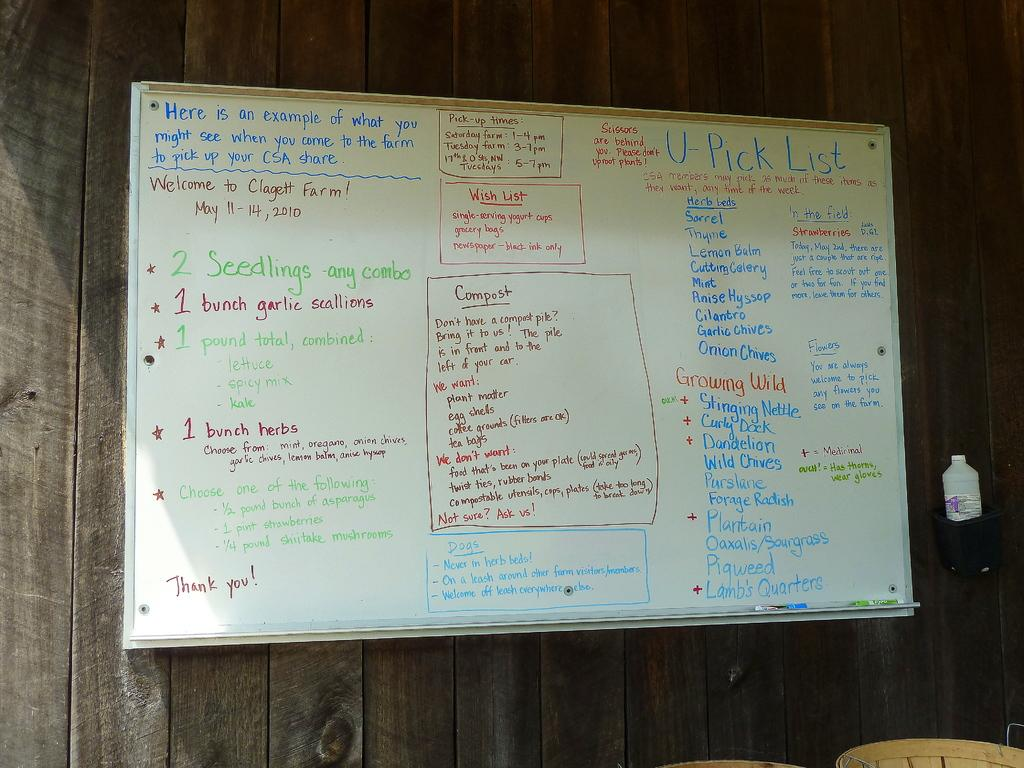<image>
Offer a succinct explanation of the picture presented. White board which says "U-Pick List" on the top right. 